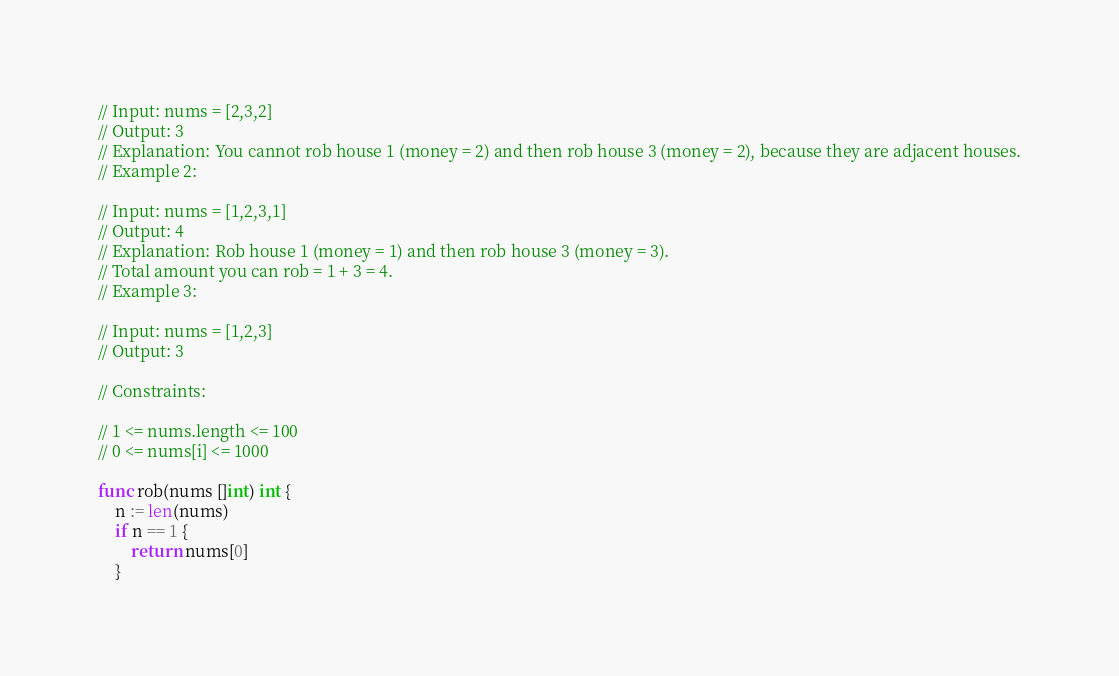<code> <loc_0><loc_0><loc_500><loc_500><_Go_>// Input: nums = [2,3,2]
// Output: 3
// Explanation: You cannot rob house 1 (money = 2) and then rob house 3 (money = 2), because they are adjacent houses.
// Example 2:

// Input: nums = [1,2,3,1]
// Output: 4
// Explanation: Rob house 1 (money = 1) and then rob house 3 (money = 3).
// Total amount you can rob = 1 + 3 = 4.
// Example 3:

// Input: nums = [1,2,3]
// Output: 3

// Constraints:

// 1 <= nums.length <= 100
// 0 <= nums[i] <= 1000

func rob(nums []int) int {
    n := len(nums)
    if n == 1 {
        return nums[0]
    }
</code> 